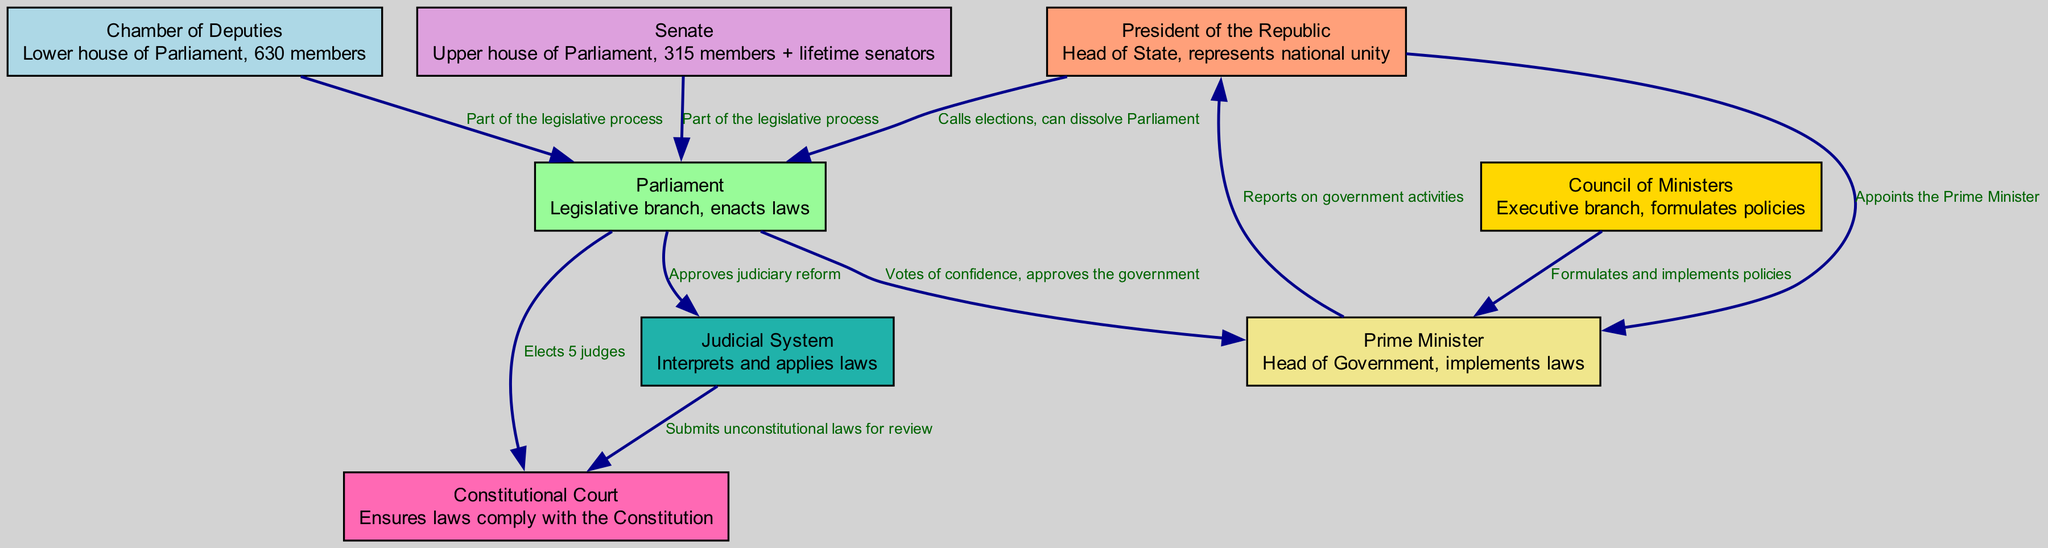What is the role of the President of the Republic? The President of the Republic acts as the Head of State and represents national unity as indicated in the diagram.
Answer: Head of State, represents national unity How many members are in the Chamber of Deputies? The diagram specifies that the Chamber of Deputies consists of 630 members.
Answer: 630 members What can the President do regarding Parliament? The diagram shows that the President can call elections and has the power to dissolve Parliament.
Answer: Calls elections, can dissolve Parliament Who appoints the Prime Minister? According to the diagram, the President of the Republic is responsible for appointing the Prime Minister.
Answer: Appoints the Prime Minister What is the relationship between Parliament and the Constitutional Court? Parliament elects 5 judges to the Constitutional Court as depicted in the diagram.
Answer: Elects 5 judges What is the primary function of the Cabinet? The diagram indicates that the Cabinet, also known as the Council of Ministers, formulates policies and implements them.
Answer: Formulates policies How many judges does Parliament elect to the Constitutional Court? The diagram clearly states that Parliament elects 5 judges to the Constitutional Court.
Answer: 5 judges Which branches does the Judicial System interact with? The Judicial System interacts with both the Constitutional Court and Parliament, as shown in the diagram.
Answer: Constitutional Court, Parliament What role does the Prime Minister have with respect to Parliament? The Prime Minister is involved with Parliament by seeking votes of confidence and gaining approval from it, as indicated in the diagram.
Answer: Votes of confidence, approves the government What does the Judicial System do in relation to unconstitutional laws? The diagram shows that the Judicial System submits unconstitutional laws for review to the Constitutional Court.
Answer: Submits unconstitutional laws for review 